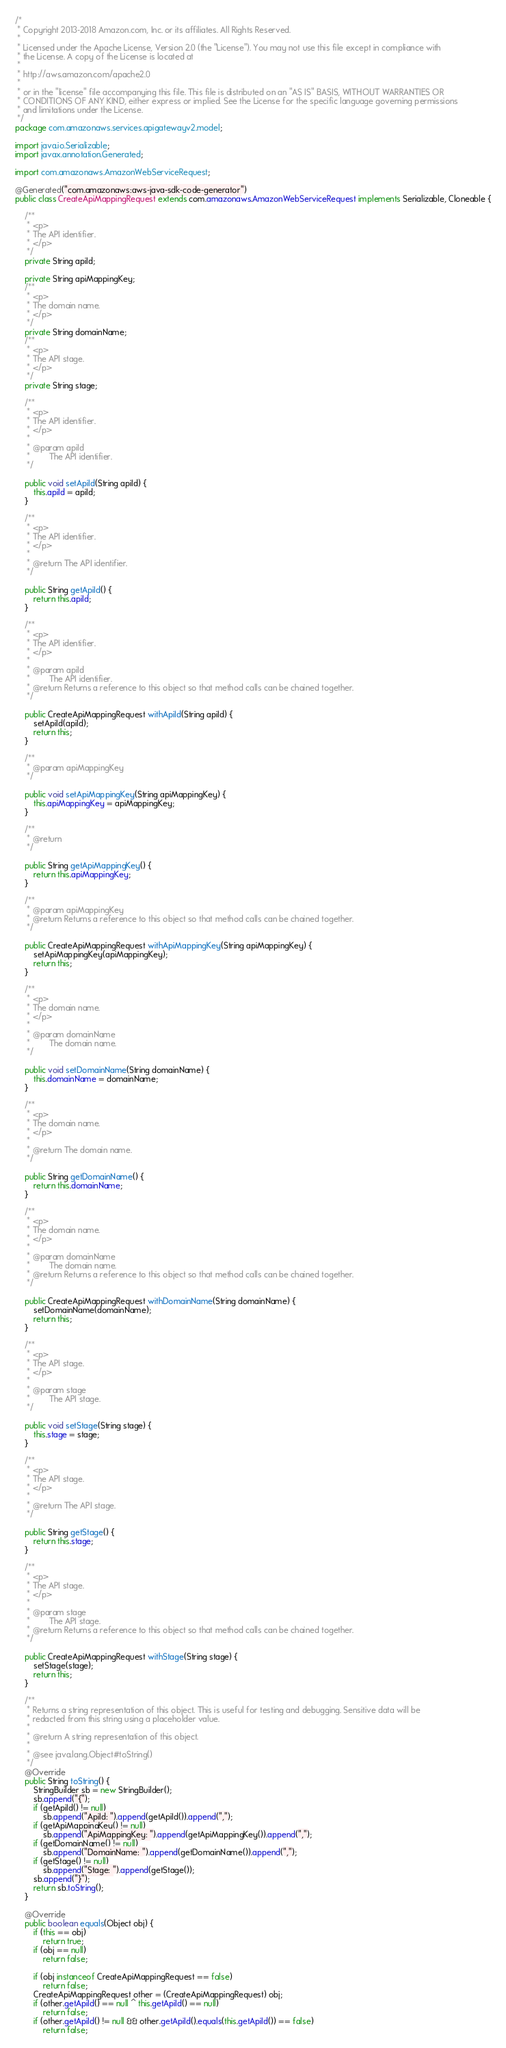<code> <loc_0><loc_0><loc_500><loc_500><_Java_>/*
 * Copyright 2013-2018 Amazon.com, Inc. or its affiliates. All Rights Reserved.
 * 
 * Licensed under the Apache License, Version 2.0 (the "License"). You may not use this file except in compliance with
 * the License. A copy of the License is located at
 * 
 * http://aws.amazon.com/apache2.0
 * 
 * or in the "license" file accompanying this file. This file is distributed on an "AS IS" BASIS, WITHOUT WARRANTIES OR
 * CONDITIONS OF ANY KIND, either express or implied. See the License for the specific language governing permissions
 * and limitations under the License.
 */
package com.amazonaws.services.apigatewayv2.model;

import java.io.Serializable;
import javax.annotation.Generated;

import com.amazonaws.AmazonWebServiceRequest;

@Generated("com.amazonaws:aws-java-sdk-code-generator")
public class CreateApiMappingRequest extends com.amazonaws.AmazonWebServiceRequest implements Serializable, Cloneable {

    /**
     * <p>
     * The API identifier.
     * </p>
     */
    private String apiId;

    private String apiMappingKey;
    /**
     * <p>
     * The domain name.
     * </p>
     */
    private String domainName;
    /**
     * <p>
     * The API stage.
     * </p>
     */
    private String stage;

    /**
     * <p>
     * The API identifier.
     * </p>
     * 
     * @param apiId
     *        The API identifier.
     */

    public void setApiId(String apiId) {
        this.apiId = apiId;
    }

    /**
     * <p>
     * The API identifier.
     * </p>
     * 
     * @return The API identifier.
     */

    public String getApiId() {
        return this.apiId;
    }

    /**
     * <p>
     * The API identifier.
     * </p>
     * 
     * @param apiId
     *        The API identifier.
     * @return Returns a reference to this object so that method calls can be chained together.
     */

    public CreateApiMappingRequest withApiId(String apiId) {
        setApiId(apiId);
        return this;
    }

    /**
     * @param apiMappingKey
     */

    public void setApiMappingKey(String apiMappingKey) {
        this.apiMappingKey = apiMappingKey;
    }

    /**
     * @return
     */

    public String getApiMappingKey() {
        return this.apiMappingKey;
    }

    /**
     * @param apiMappingKey
     * @return Returns a reference to this object so that method calls can be chained together.
     */

    public CreateApiMappingRequest withApiMappingKey(String apiMappingKey) {
        setApiMappingKey(apiMappingKey);
        return this;
    }

    /**
     * <p>
     * The domain name.
     * </p>
     * 
     * @param domainName
     *        The domain name.
     */

    public void setDomainName(String domainName) {
        this.domainName = domainName;
    }

    /**
     * <p>
     * The domain name.
     * </p>
     * 
     * @return The domain name.
     */

    public String getDomainName() {
        return this.domainName;
    }

    /**
     * <p>
     * The domain name.
     * </p>
     * 
     * @param domainName
     *        The domain name.
     * @return Returns a reference to this object so that method calls can be chained together.
     */

    public CreateApiMappingRequest withDomainName(String domainName) {
        setDomainName(domainName);
        return this;
    }

    /**
     * <p>
     * The API stage.
     * </p>
     * 
     * @param stage
     *        The API stage.
     */

    public void setStage(String stage) {
        this.stage = stage;
    }

    /**
     * <p>
     * The API stage.
     * </p>
     * 
     * @return The API stage.
     */

    public String getStage() {
        return this.stage;
    }

    /**
     * <p>
     * The API stage.
     * </p>
     * 
     * @param stage
     *        The API stage.
     * @return Returns a reference to this object so that method calls can be chained together.
     */

    public CreateApiMappingRequest withStage(String stage) {
        setStage(stage);
        return this;
    }

    /**
     * Returns a string representation of this object. This is useful for testing and debugging. Sensitive data will be
     * redacted from this string using a placeholder value.
     *
     * @return A string representation of this object.
     *
     * @see java.lang.Object#toString()
     */
    @Override
    public String toString() {
        StringBuilder sb = new StringBuilder();
        sb.append("{");
        if (getApiId() != null)
            sb.append("ApiId: ").append(getApiId()).append(",");
        if (getApiMappingKey() != null)
            sb.append("ApiMappingKey: ").append(getApiMappingKey()).append(",");
        if (getDomainName() != null)
            sb.append("DomainName: ").append(getDomainName()).append(",");
        if (getStage() != null)
            sb.append("Stage: ").append(getStage());
        sb.append("}");
        return sb.toString();
    }

    @Override
    public boolean equals(Object obj) {
        if (this == obj)
            return true;
        if (obj == null)
            return false;

        if (obj instanceof CreateApiMappingRequest == false)
            return false;
        CreateApiMappingRequest other = (CreateApiMappingRequest) obj;
        if (other.getApiId() == null ^ this.getApiId() == null)
            return false;
        if (other.getApiId() != null && other.getApiId().equals(this.getApiId()) == false)
            return false;</code> 